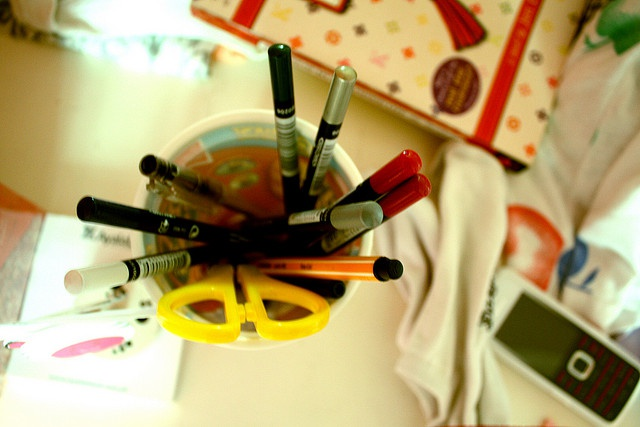Describe the objects in this image and their specific colors. I can see book in black, khaki, tan, olive, and brown tones, cell phone in black, beige, darkgreen, and olive tones, and scissors in black, gold, orange, olive, and maroon tones in this image. 